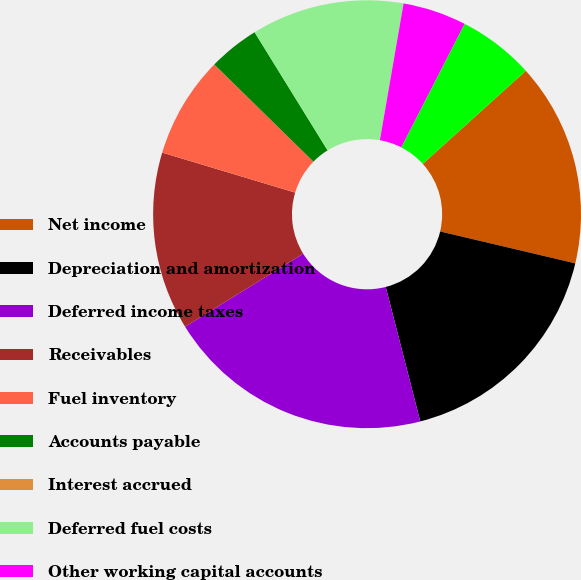Convert chart. <chart><loc_0><loc_0><loc_500><loc_500><pie_chart><fcel>Net income<fcel>Depreciation and amortization<fcel>Deferred income taxes<fcel>Receivables<fcel>Fuel inventory<fcel>Accounts payable<fcel>Interest accrued<fcel>Deferred fuel costs<fcel>Other working capital accounts<fcel>Provisions for estimated<nl><fcel>15.38%<fcel>17.31%<fcel>20.19%<fcel>13.46%<fcel>7.69%<fcel>3.85%<fcel>0.0%<fcel>11.54%<fcel>4.81%<fcel>5.77%<nl></chart> 